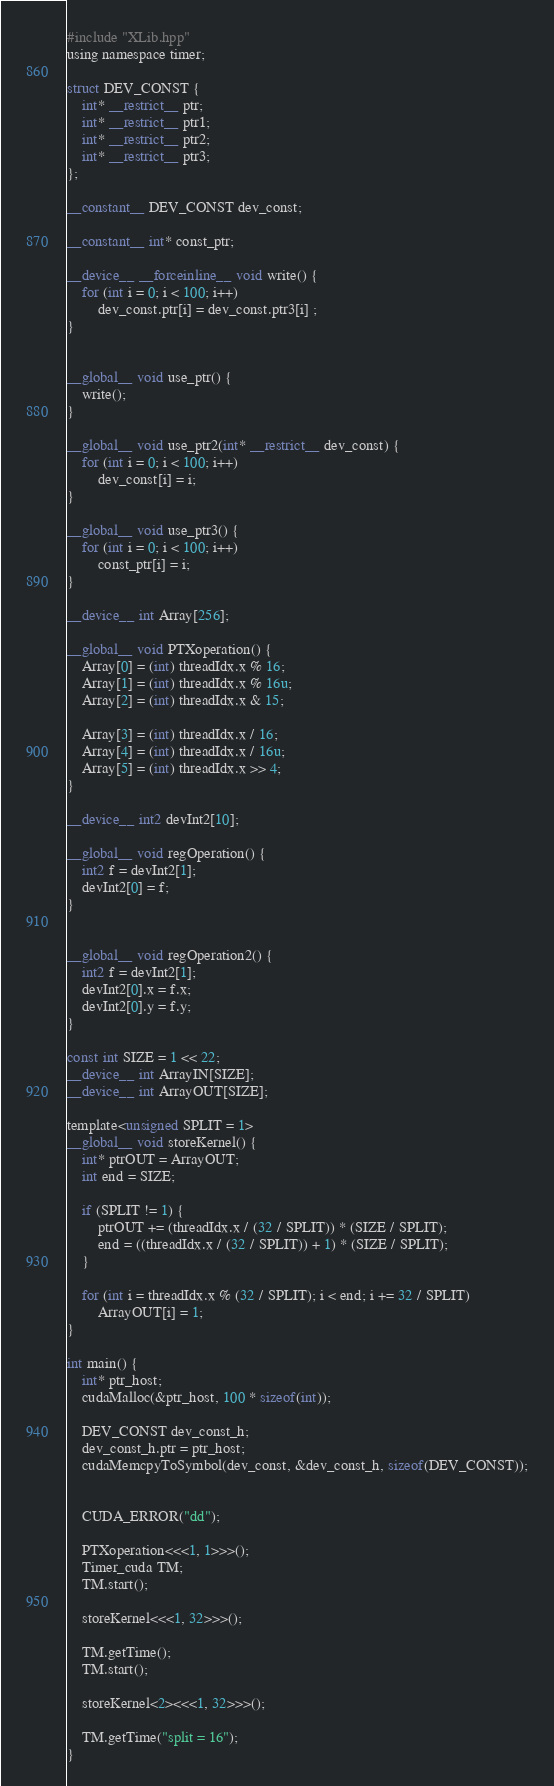Convert code to text. <code><loc_0><loc_0><loc_500><loc_500><_Cuda_>#include "XLib.hpp"
using namespace timer;

struct DEV_CONST {
    int* __restrict__ ptr;
    int* __restrict__ ptr1;
    int* __restrict__ ptr2;
    int* __restrict__ ptr3;
};

__constant__ DEV_CONST dev_const;

__constant__ int* const_ptr;

__device__ __forceinline__ void write() {
    for (int i = 0; i < 100; i++)
        dev_const.ptr[i] = dev_const.ptr3[i] ;
}


__global__ void use_ptr() {
    write();
}

__global__ void use_ptr2(int* __restrict__ dev_const) {
    for (int i = 0; i < 100; i++)
        dev_const[i] = i;
}

__global__ void use_ptr3() {
    for (int i = 0; i < 100; i++)
        const_ptr[i] = i;
}

__device__ int Array[256];

__global__ void PTXoperation() {
    Array[0] = (int) threadIdx.x % 16;
    Array[1] = (int) threadIdx.x % 16u;
    Array[2] = (int) threadIdx.x & 15;

    Array[3] = (int) threadIdx.x / 16;
    Array[4] = (int) threadIdx.x / 16u;
    Array[5] = (int) threadIdx.x >> 4;
}

__device__ int2 devInt2[10];

__global__ void regOperation() {
    int2 f = devInt2[1];
    devInt2[0] = f;
}


__global__ void regOperation2() {
    int2 f = devInt2[1];
    devInt2[0].x = f.x;
    devInt2[0].y = f.y;
}

const int SIZE = 1 << 22;
__device__ int ArrayIN[SIZE];
__device__ int ArrayOUT[SIZE];

template<unsigned SPLIT = 1>
__global__ void storeKernel() {
    int* ptrOUT = ArrayOUT;
    int end = SIZE;

    if (SPLIT != 1) {
        ptrOUT += (threadIdx.x / (32 / SPLIT)) * (SIZE / SPLIT);
        end = ((threadIdx.x / (32 / SPLIT)) + 1) * (SIZE / SPLIT);
    }

    for (int i = threadIdx.x % (32 / SPLIT); i < end; i += 32 / SPLIT)
        ArrayOUT[i] = 1;
}

int main() {
    int* ptr_host;
    cudaMalloc(&ptr_host, 100 * sizeof(int));

    DEV_CONST dev_const_h;
    dev_const_h.ptr = ptr_host;
    cudaMemcpyToSymbol(dev_const, &dev_const_h, sizeof(DEV_CONST));


    CUDA_ERROR("dd");

    PTXoperation<<<1, 1>>>();
    Timer_cuda TM;
    TM.start();

    storeKernel<<<1, 32>>>();

    TM.getTime();
    TM.start();

    storeKernel<2><<<1, 32>>>();

    TM.getTime("split = 16");
}
</code> 